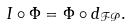Convert formula to latex. <formula><loc_0><loc_0><loc_500><loc_500>I \circ \Phi = \Phi \circ d _ { \mathcal { F P } } .</formula> 